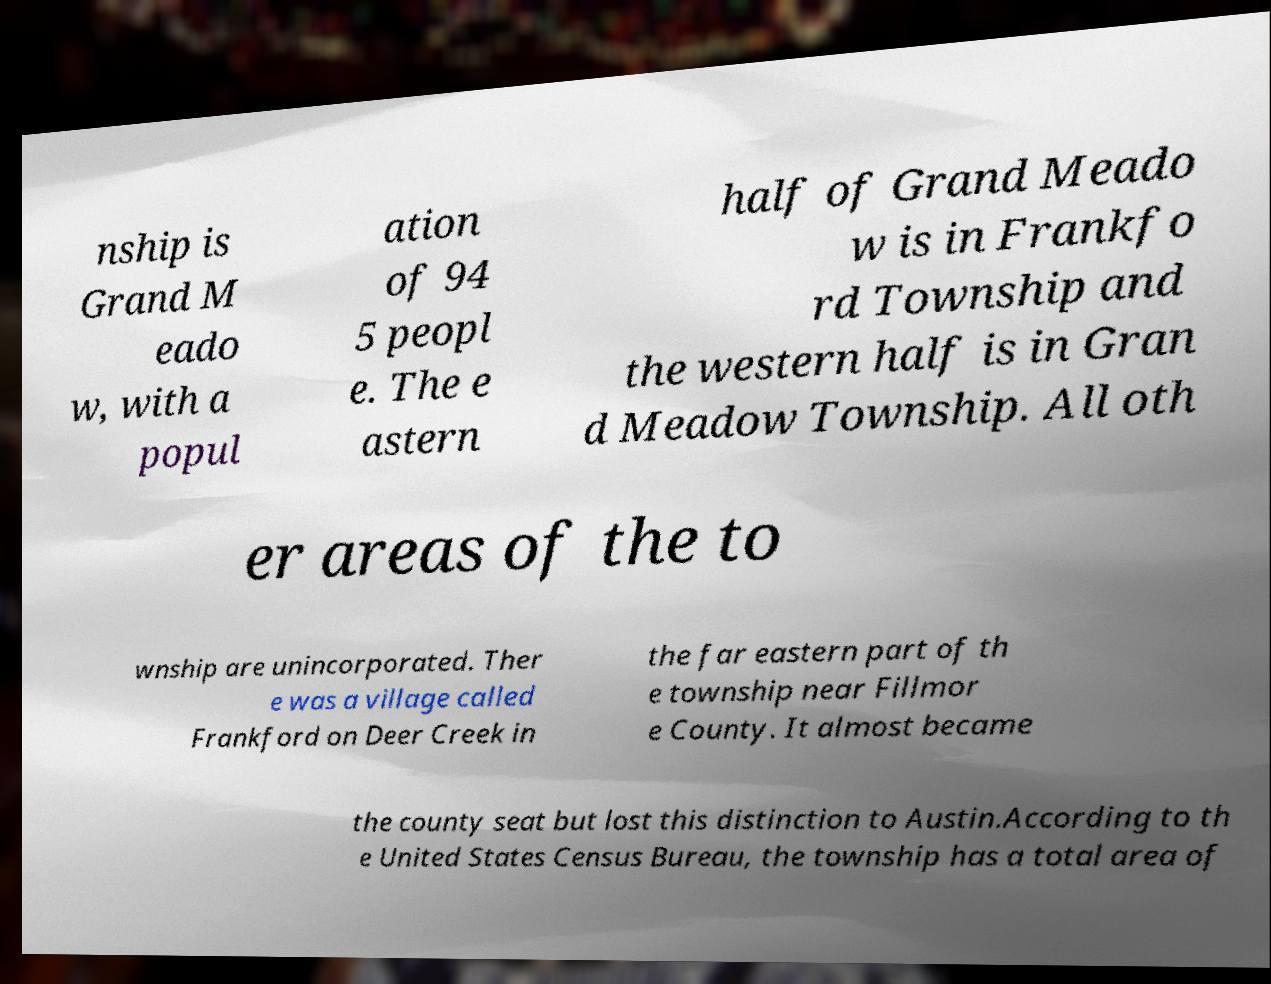I need the written content from this picture converted into text. Can you do that? nship is Grand M eado w, with a popul ation of 94 5 peopl e. The e astern half of Grand Meado w is in Frankfo rd Township and the western half is in Gran d Meadow Township. All oth er areas of the to wnship are unincorporated. Ther e was a village called Frankford on Deer Creek in the far eastern part of th e township near Fillmor e County. It almost became the county seat but lost this distinction to Austin.According to th e United States Census Bureau, the township has a total area of 